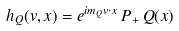<formula> <loc_0><loc_0><loc_500><loc_500>h _ { Q } ( v , x ) = e ^ { i m _ { Q } v \cdot x } \, P _ { + } \, Q ( x )</formula> 